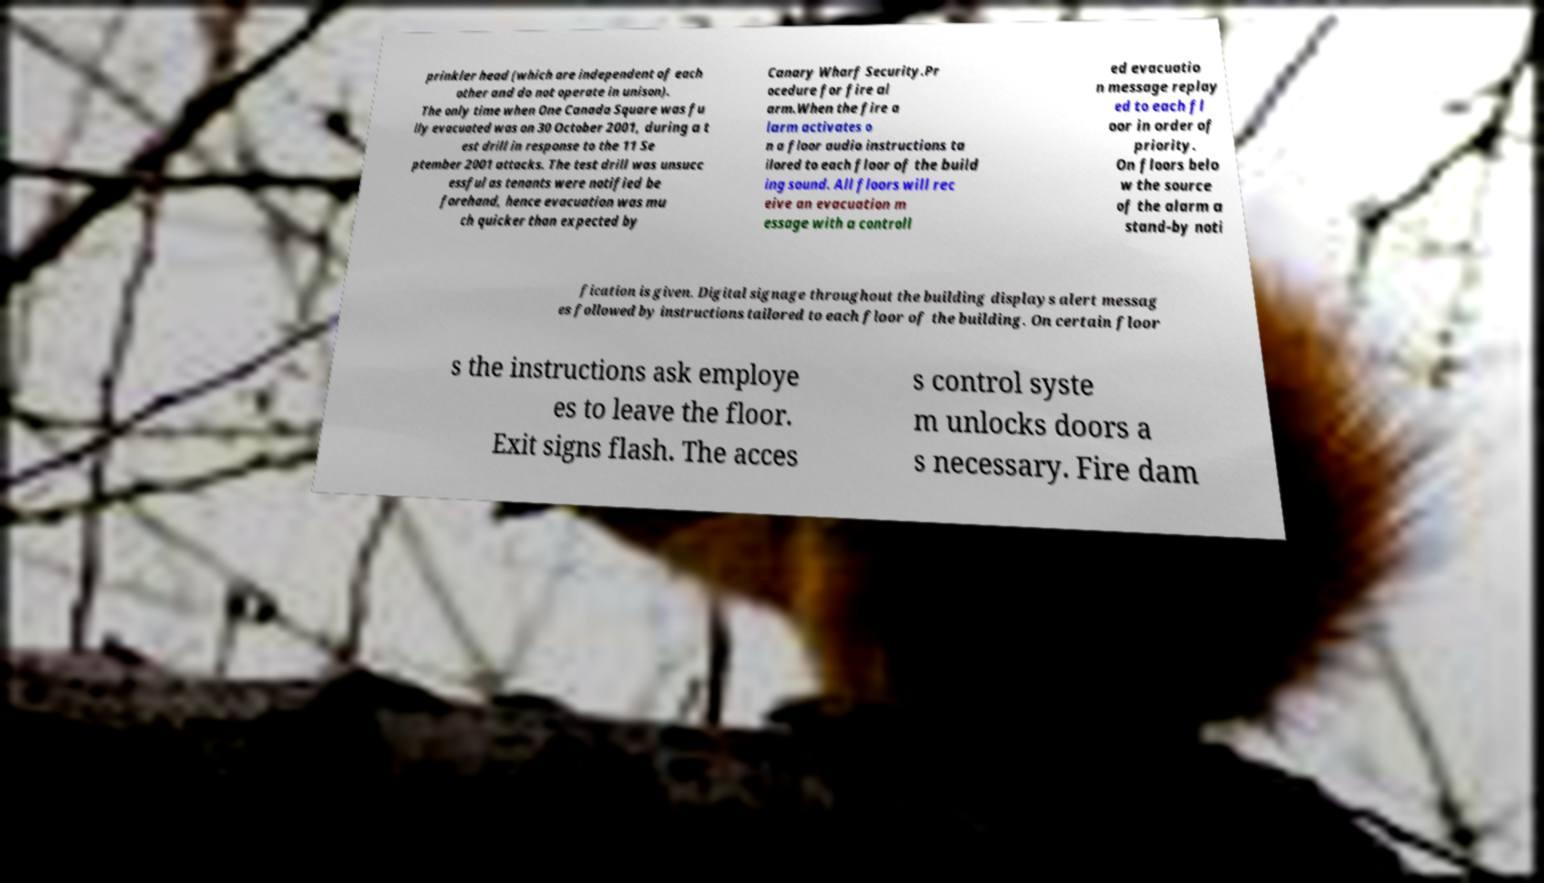Please read and relay the text visible in this image. What does it say? prinkler head (which are independent of each other and do not operate in unison). The only time when One Canada Square was fu lly evacuated was on 30 October 2001, during a t est drill in response to the 11 Se ptember 2001 attacks. The test drill was unsucc essful as tenants were notified be forehand, hence evacuation was mu ch quicker than expected by Canary Wharf Security.Pr ocedure for fire al arm.When the fire a larm activates o n a floor audio instructions ta ilored to each floor of the build ing sound. All floors will rec eive an evacuation m essage with a controll ed evacuatio n message replay ed to each fl oor in order of priority. On floors belo w the source of the alarm a stand-by noti fication is given. Digital signage throughout the building displays alert messag es followed by instructions tailored to each floor of the building. On certain floor s the instructions ask employe es to leave the floor. Exit signs flash. The acces s control syste m unlocks doors a s necessary. Fire dam 